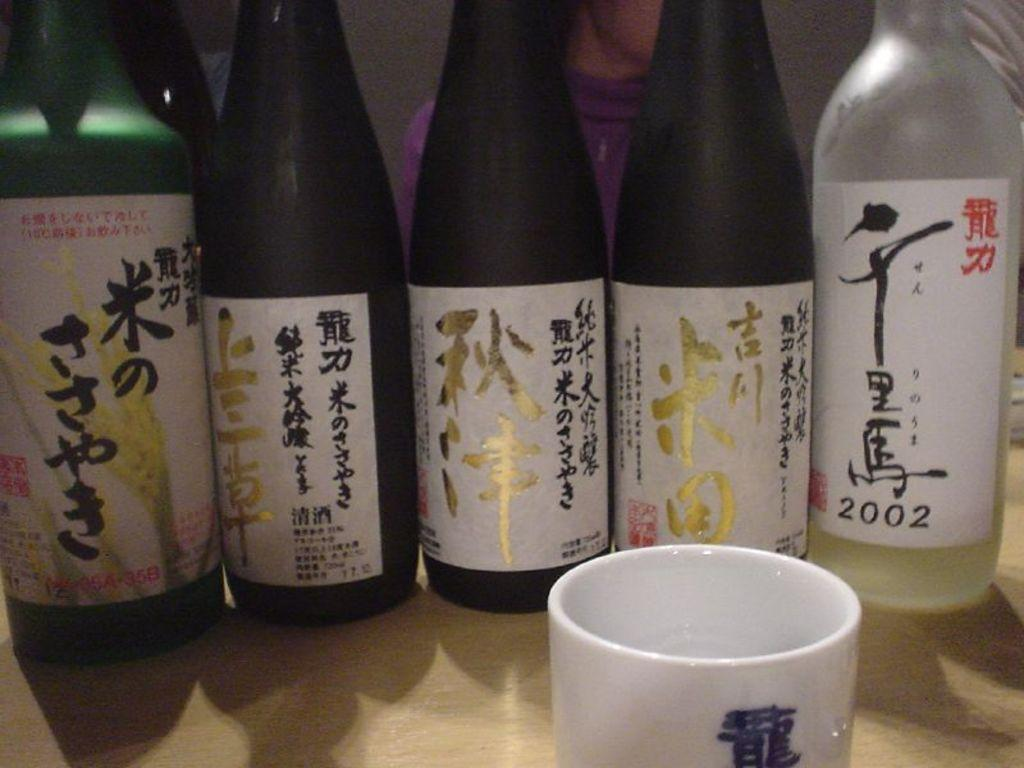<image>
Render a clear and concise summary of the photo. Of the bottles of Japanese liquor, one was produced in 2002. 